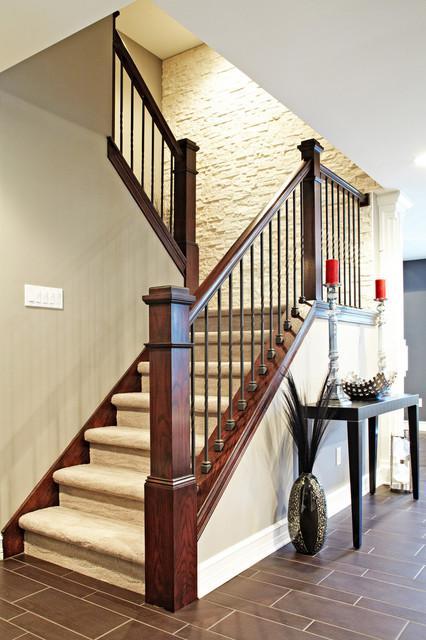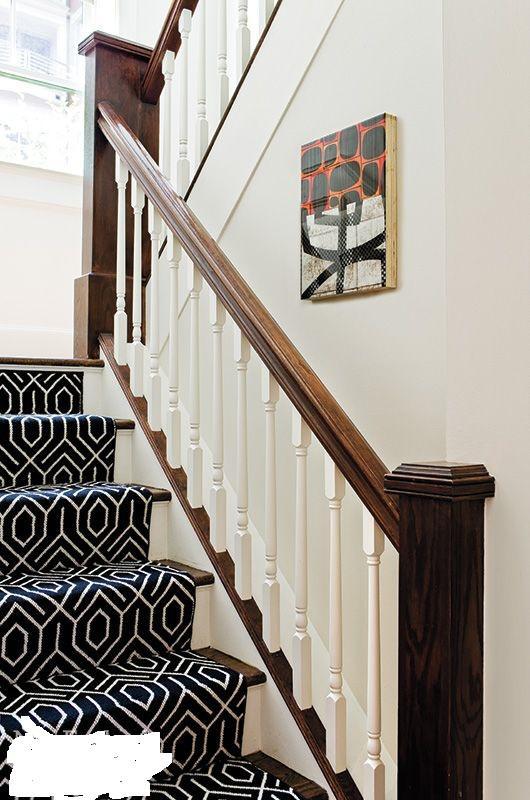The first image is the image on the left, the second image is the image on the right. Evaluate the accuracy of this statement regarding the images: "One staircase has a white side edge and descends without turns midway, and the other staircase has zig-zag turns.". Is it true? Answer yes or no. No. 